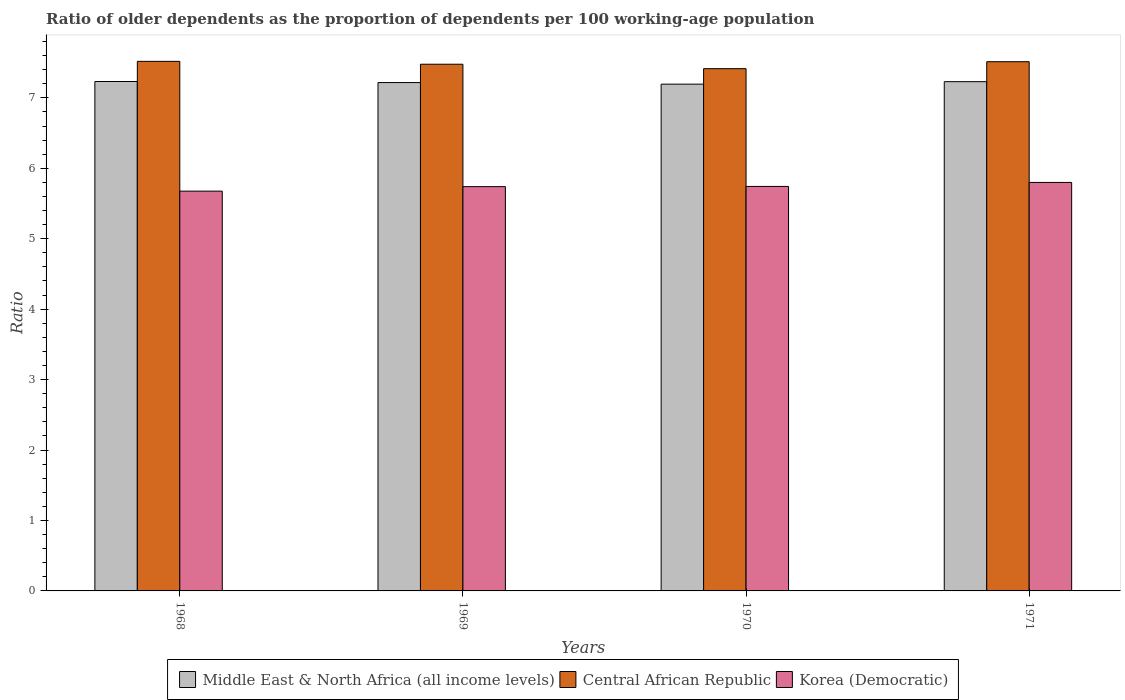How many groups of bars are there?
Offer a terse response. 4. Are the number of bars on each tick of the X-axis equal?
Provide a short and direct response. Yes. How many bars are there on the 3rd tick from the left?
Give a very brief answer. 3. What is the label of the 1st group of bars from the left?
Keep it short and to the point. 1968. What is the age dependency ratio(old) in Middle East & North Africa (all income levels) in 1971?
Provide a succinct answer. 7.23. Across all years, what is the maximum age dependency ratio(old) in Central African Republic?
Give a very brief answer. 7.52. Across all years, what is the minimum age dependency ratio(old) in Middle East & North Africa (all income levels)?
Your answer should be very brief. 7.19. In which year was the age dependency ratio(old) in Middle East & North Africa (all income levels) maximum?
Keep it short and to the point. 1968. In which year was the age dependency ratio(old) in Korea (Democratic) minimum?
Provide a short and direct response. 1968. What is the total age dependency ratio(old) in Middle East & North Africa (all income levels) in the graph?
Offer a terse response. 28.87. What is the difference between the age dependency ratio(old) in Middle East & North Africa (all income levels) in 1968 and that in 1971?
Offer a terse response. 0. What is the difference between the age dependency ratio(old) in Middle East & North Africa (all income levels) in 1969 and the age dependency ratio(old) in Korea (Democratic) in 1970?
Offer a very short reply. 1.47. What is the average age dependency ratio(old) in Central African Republic per year?
Give a very brief answer. 7.48. In the year 1969, what is the difference between the age dependency ratio(old) in Central African Republic and age dependency ratio(old) in Korea (Democratic)?
Provide a succinct answer. 1.74. What is the ratio of the age dependency ratio(old) in Korea (Democratic) in 1969 to that in 1971?
Your response must be concise. 0.99. Is the age dependency ratio(old) in Central African Republic in 1969 less than that in 1970?
Ensure brevity in your answer.  No. What is the difference between the highest and the second highest age dependency ratio(old) in Middle East & North Africa (all income levels)?
Keep it short and to the point. 0. What is the difference between the highest and the lowest age dependency ratio(old) in Central African Republic?
Offer a very short reply. 0.1. In how many years, is the age dependency ratio(old) in Middle East & North Africa (all income levels) greater than the average age dependency ratio(old) in Middle East & North Africa (all income levels) taken over all years?
Make the answer very short. 2. Is the sum of the age dependency ratio(old) in Korea (Democratic) in 1969 and 1970 greater than the maximum age dependency ratio(old) in Middle East & North Africa (all income levels) across all years?
Your response must be concise. Yes. What does the 3rd bar from the left in 1970 represents?
Your response must be concise. Korea (Democratic). What does the 1st bar from the right in 1970 represents?
Offer a terse response. Korea (Democratic). How many bars are there?
Ensure brevity in your answer.  12. Does the graph contain any zero values?
Your response must be concise. No. Does the graph contain grids?
Ensure brevity in your answer.  No. What is the title of the graph?
Offer a very short reply. Ratio of older dependents as the proportion of dependents per 100 working-age population. Does "France" appear as one of the legend labels in the graph?
Give a very brief answer. No. What is the label or title of the Y-axis?
Offer a terse response. Ratio. What is the Ratio in Middle East & North Africa (all income levels) in 1968?
Your answer should be very brief. 7.23. What is the Ratio in Central African Republic in 1968?
Offer a very short reply. 7.52. What is the Ratio of Korea (Democratic) in 1968?
Make the answer very short. 5.68. What is the Ratio of Middle East & North Africa (all income levels) in 1969?
Ensure brevity in your answer.  7.22. What is the Ratio of Central African Republic in 1969?
Offer a very short reply. 7.48. What is the Ratio in Korea (Democratic) in 1969?
Provide a succinct answer. 5.74. What is the Ratio of Middle East & North Africa (all income levels) in 1970?
Offer a very short reply. 7.19. What is the Ratio of Central African Republic in 1970?
Offer a terse response. 7.41. What is the Ratio of Korea (Democratic) in 1970?
Make the answer very short. 5.74. What is the Ratio in Middle East & North Africa (all income levels) in 1971?
Offer a very short reply. 7.23. What is the Ratio of Central African Republic in 1971?
Your answer should be compact. 7.51. What is the Ratio in Korea (Democratic) in 1971?
Your response must be concise. 5.8. Across all years, what is the maximum Ratio of Middle East & North Africa (all income levels)?
Offer a very short reply. 7.23. Across all years, what is the maximum Ratio of Central African Republic?
Keep it short and to the point. 7.52. Across all years, what is the maximum Ratio of Korea (Democratic)?
Keep it short and to the point. 5.8. Across all years, what is the minimum Ratio of Middle East & North Africa (all income levels)?
Your response must be concise. 7.19. Across all years, what is the minimum Ratio of Central African Republic?
Provide a short and direct response. 7.41. Across all years, what is the minimum Ratio of Korea (Democratic)?
Provide a short and direct response. 5.68. What is the total Ratio of Middle East & North Africa (all income levels) in the graph?
Give a very brief answer. 28.87. What is the total Ratio in Central African Republic in the graph?
Give a very brief answer. 29.92. What is the total Ratio of Korea (Democratic) in the graph?
Keep it short and to the point. 22.96. What is the difference between the Ratio in Middle East & North Africa (all income levels) in 1968 and that in 1969?
Offer a terse response. 0.02. What is the difference between the Ratio of Central African Republic in 1968 and that in 1969?
Your answer should be very brief. 0.04. What is the difference between the Ratio in Korea (Democratic) in 1968 and that in 1969?
Your answer should be very brief. -0.06. What is the difference between the Ratio of Middle East & North Africa (all income levels) in 1968 and that in 1970?
Keep it short and to the point. 0.04. What is the difference between the Ratio of Central African Republic in 1968 and that in 1970?
Keep it short and to the point. 0.1. What is the difference between the Ratio in Korea (Democratic) in 1968 and that in 1970?
Provide a short and direct response. -0.07. What is the difference between the Ratio of Middle East & North Africa (all income levels) in 1968 and that in 1971?
Keep it short and to the point. 0. What is the difference between the Ratio in Central African Republic in 1968 and that in 1971?
Offer a terse response. 0.01. What is the difference between the Ratio in Korea (Democratic) in 1968 and that in 1971?
Ensure brevity in your answer.  -0.12. What is the difference between the Ratio in Middle East & North Africa (all income levels) in 1969 and that in 1970?
Your response must be concise. 0.02. What is the difference between the Ratio of Central African Republic in 1969 and that in 1970?
Provide a succinct answer. 0.06. What is the difference between the Ratio of Korea (Democratic) in 1969 and that in 1970?
Ensure brevity in your answer.  -0. What is the difference between the Ratio in Middle East & North Africa (all income levels) in 1969 and that in 1971?
Offer a very short reply. -0.01. What is the difference between the Ratio in Central African Republic in 1969 and that in 1971?
Make the answer very short. -0.04. What is the difference between the Ratio of Korea (Democratic) in 1969 and that in 1971?
Make the answer very short. -0.06. What is the difference between the Ratio of Middle East & North Africa (all income levels) in 1970 and that in 1971?
Provide a succinct answer. -0.04. What is the difference between the Ratio of Central African Republic in 1970 and that in 1971?
Your response must be concise. -0.1. What is the difference between the Ratio in Korea (Democratic) in 1970 and that in 1971?
Offer a terse response. -0.06. What is the difference between the Ratio of Middle East & North Africa (all income levels) in 1968 and the Ratio of Central African Republic in 1969?
Keep it short and to the point. -0.25. What is the difference between the Ratio in Middle East & North Africa (all income levels) in 1968 and the Ratio in Korea (Democratic) in 1969?
Your answer should be compact. 1.49. What is the difference between the Ratio in Central African Republic in 1968 and the Ratio in Korea (Democratic) in 1969?
Your response must be concise. 1.78. What is the difference between the Ratio of Middle East & North Africa (all income levels) in 1968 and the Ratio of Central African Republic in 1970?
Your answer should be very brief. -0.18. What is the difference between the Ratio of Middle East & North Africa (all income levels) in 1968 and the Ratio of Korea (Democratic) in 1970?
Keep it short and to the point. 1.49. What is the difference between the Ratio in Central African Republic in 1968 and the Ratio in Korea (Democratic) in 1970?
Offer a terse response. 1.78. What is the difference between the Ratio in Middle East & North Africa (all income levels) in 1968 and the Ratio in Central African Republic in 1971?
Ensure brevity in your answer.  -0.28. What is the difference between the Ratio of Middle East & North Africa (all income levels) in 1968 and the Ratio of Korea (Democratic) in 1971?
Keep it short and to the point. 1.43. What is the difference between the Ratio in Central African Republic in 1968 and the Ratio in Korea (Democratic) in 1971?
Offer a terse response. 1.72. What is the difference between the Ratio of Middle East & North Africa (all income levels) in 1969 and the Ratio of Central African Republic in 1970?
Your response must be concise. -0.2. What is the difference between the Ratio in Middle East & North Africa (all income levels) in 1969 and the Ratio in Korea (Democratic) in 1970?
Offer a very short reply. 1.47. What is the difference between the Ratio of Central African Republic in 1969 and the Ratio of Korea (Democratic) in 1970?
Your response must be concise. 1.73. What is the difference between the Ratio in Middle East & North Africa (all income levels) in 1969 and the Ratio in Central African Republic in 1971?
Your response must be concise. -0.3. What is the difference between the Ratio of Middle East & North Africa (all income levels) in 1969 and the Ratio of Korea (Democratic) in 1971?
Offer a very short reply. 1.42. What is the difference between the Ratio of Central African Republic in 1969 and the Ratio of Korea (Democratic) in 1971?
Make the answer very short. 1.68. What is the difference between the Ratio of Middle East & North Africa (all income levels) in 1970 and the Ratio of Central African Republic in 1971?
Offer a very short reply. -0.32. What is the difference between the Ratio in Middle East & North Africa (all income levels) in 1970 and the Ratio in Korea (Democratic) in 1971?
Your response must be concise. 1.4. What is the difference between the Ratio of Central African Republic in 1970 and the Ratio of Korea (Democratic) in 1971?
Ensure brevity in your answer.  1.62. What is the average Ratio of Middle East & North Africa (all income levels) per year?
Make the answer very short. 7.22. What is the average Ratio in Central African Republic per year?
Give a very brief answer. 7.48. What is the average Ratio of Korea (Democratic) per year?
Give a very brief answer. 5.74. In the year 1968, what is the difference between the Ratio in Middle East & North Africa (all income levels) and Ratio in Central African Republic?
Your response must be concise. -0.29. In the year 1968, what is the difference between the Ratio of Middle East & North Africa (all income levels) and Ratio of Korea (Democratic)?
Provide a short and direct response. 1.56. In the year 1968, what is the difference between the Ratio of Central African Republic and Ratio of Korea (Democratic)?
Your answer should be compact. 1.84. In the year 1969, what is the difference between the Ratio in Middle East & North Africa (all income levels) and Ratio in Central African Republic?
Your answer should be very brief. -0.26. In the year 1969, what is the difference between the Ratio in Middle East & North Africa (all income levels) and Ratio in Korea (Democratic)?
Offer a very short reply. 1.48. In the year 1969, what is the difference between the Ratio in Central African Republic and Ratio in Korea (Democratic)?
Provide a short and direct response. 1.74. In the year 1970, what is the difference between the Ratio in Middle East & North Africa (all income levels) and Ratio in Central African Republic?
Offer a terse response. -0.22. In the year 1970, what is the difference between the Ratio of Middle East & North Africa (all income levels) and Ratio of Korea (Democratic)?
Your answer should be compact. 1.45. In the year 1970, what is the difference between the Ratio in Central African Republic and Ratio in Korea (Democratic)?
Make the answer very short. 1.67. In the year 1971, what is the difference between the Ratio of Middle East & North Africa (all income levels) and Ratio of Central African Republic?
Your response must be concise. -0.28. In the year 1971, what is the difference between the Ratio of Middle East & North Africa (all income levels) and Ratio of Korea (Democratic)?
Your answer should be compact. 1.43. In the year 1971, what is the difference between the Ratio of Central African Republic and Ratio of Korea (Democratic)?
Provide a succinct answer. 1.71. What is the ratio of the Ratio of Middle East & North Africa (all income levels) in 1968 to that in 1969?
Your answer should be very brief. 1. What is the ratio of the Ratio of Korea (Democratic) in 1968 to that in 1969?
Keep it short and to the point. 0.99. What is the ratio of the Ratio in Central African Republic in 1968 to that in 1970?
Give a very brief answer. 1.01. What is the ratio of the Ratio of Korea (Democratic) in 1968 to that in 1970?
Your answer should be compact. 0.99. What is the ratio of the Ratio in Central African Republic in 1968 to that in 1971?
Provide a succinct answer. 1. What is the ratio of the Ratio in Korea (Democratic) in 1968 to that in 1971?
Your answer should be very brief. 0.98. What is the ratio of the Ratio in Central African Republic in 1969 to that in 1970?
Make the answer very short. 1.01. What is the ratio of the Ratio in Middle East & North Africa (all income levels) in 1969 to that in 1971?
Give a very brief answer. 1. What is the ratio of the Ratio of Central African Republic in 1969 to that in 1971?
Provide a succinct answer. 1. What is the ratio of the Ratio of Central African Republic in 1970 to that in 1971?
Your response must be concise. 0.99. What is the ratio of the Ratio in Korea (Democratic) in 1970 to that in 1971?
Provide a succinct answer. 0.99. What is the difference between the highest and the second highest Ratio of Middle East & North Africa (all income levels)?
Give a very brief answer. 0. What is the difference between the highest and the second highest Ratio of Central African Republic?
Keep it short and to the point. 0.01. What is the difference between the highest and the second highest Ratio of Korea (Democratic)?
Provide a short and direct response. 0.06. What is the difference between the highest and the lowest Ratio of Middle East & North Africa (all income levels)?
Your answer should be compact. 0.04. What is the difference between the highest and the lowest Ratio of Central African Republic?
Your answer should be compact. 0.1. What is the difference between the highest and the lowest Ratio in Korea (Democratic)?
Provide a short and direct response. 0.12. 